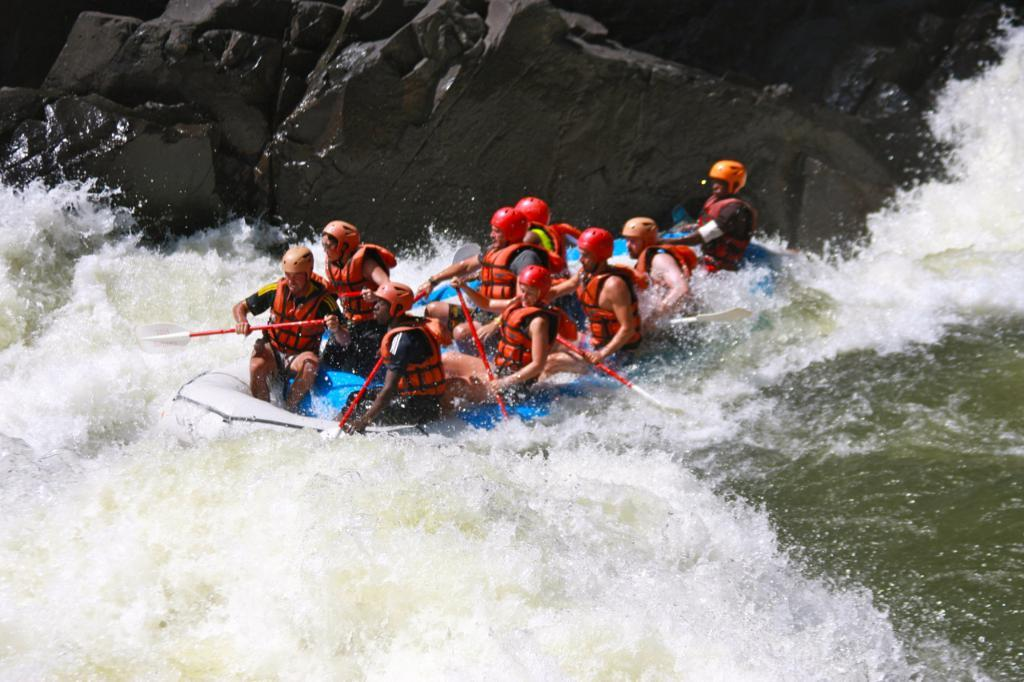What activity are the people in the image participating in? The people are rafting in white water. Can you describe the setting of the image? The people are rafting in a river with white water rapids. What is visible at the top of the image? There is a rock visible at the top of the image. What type of authority figure can be seen arguing with the group of people in the image? There is no authority figure or argument present in the image; it features a group of people rafting in white water. 